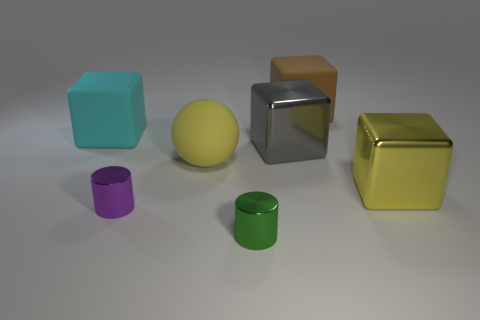What number of big cubes have the same color as the large sphere?
Ensure brevity in your answer.  1. There is a object that is the same color as the big sphere; what material is it?
Offer a very short reply. Metal. Is there anything else that is the same shape as the yellow rubber object?
Your answer should be very brief. No. What number of other things are the same color as the big matte ball?
Make the answer very short. 1. Is the number of tiny objects that are right of the green metallic cylinder less than the number of yellow objects to the left of the big yellow metal thing?
Ensure brevity in your answer.  Yes. How many large yellow objects are the same shape as the green thing?
Offer a very short reply. 0. There is a gray cube that is made of the same material as the small purple cylinder; what is its size?
Keep it short and to the point. Large. What is the color of the matte thing that is on the right side of the big metal object that is on the left side of the brown cube?
Provide a succinct answer. Brown. There is a small purple object; is it the same shape as the small thing that is in front of the purple shiny cylinder?
Offer a very short reply. Yes. What number of purple metal objects are the same size as the green object?
Provide a short and direct response. 1. 